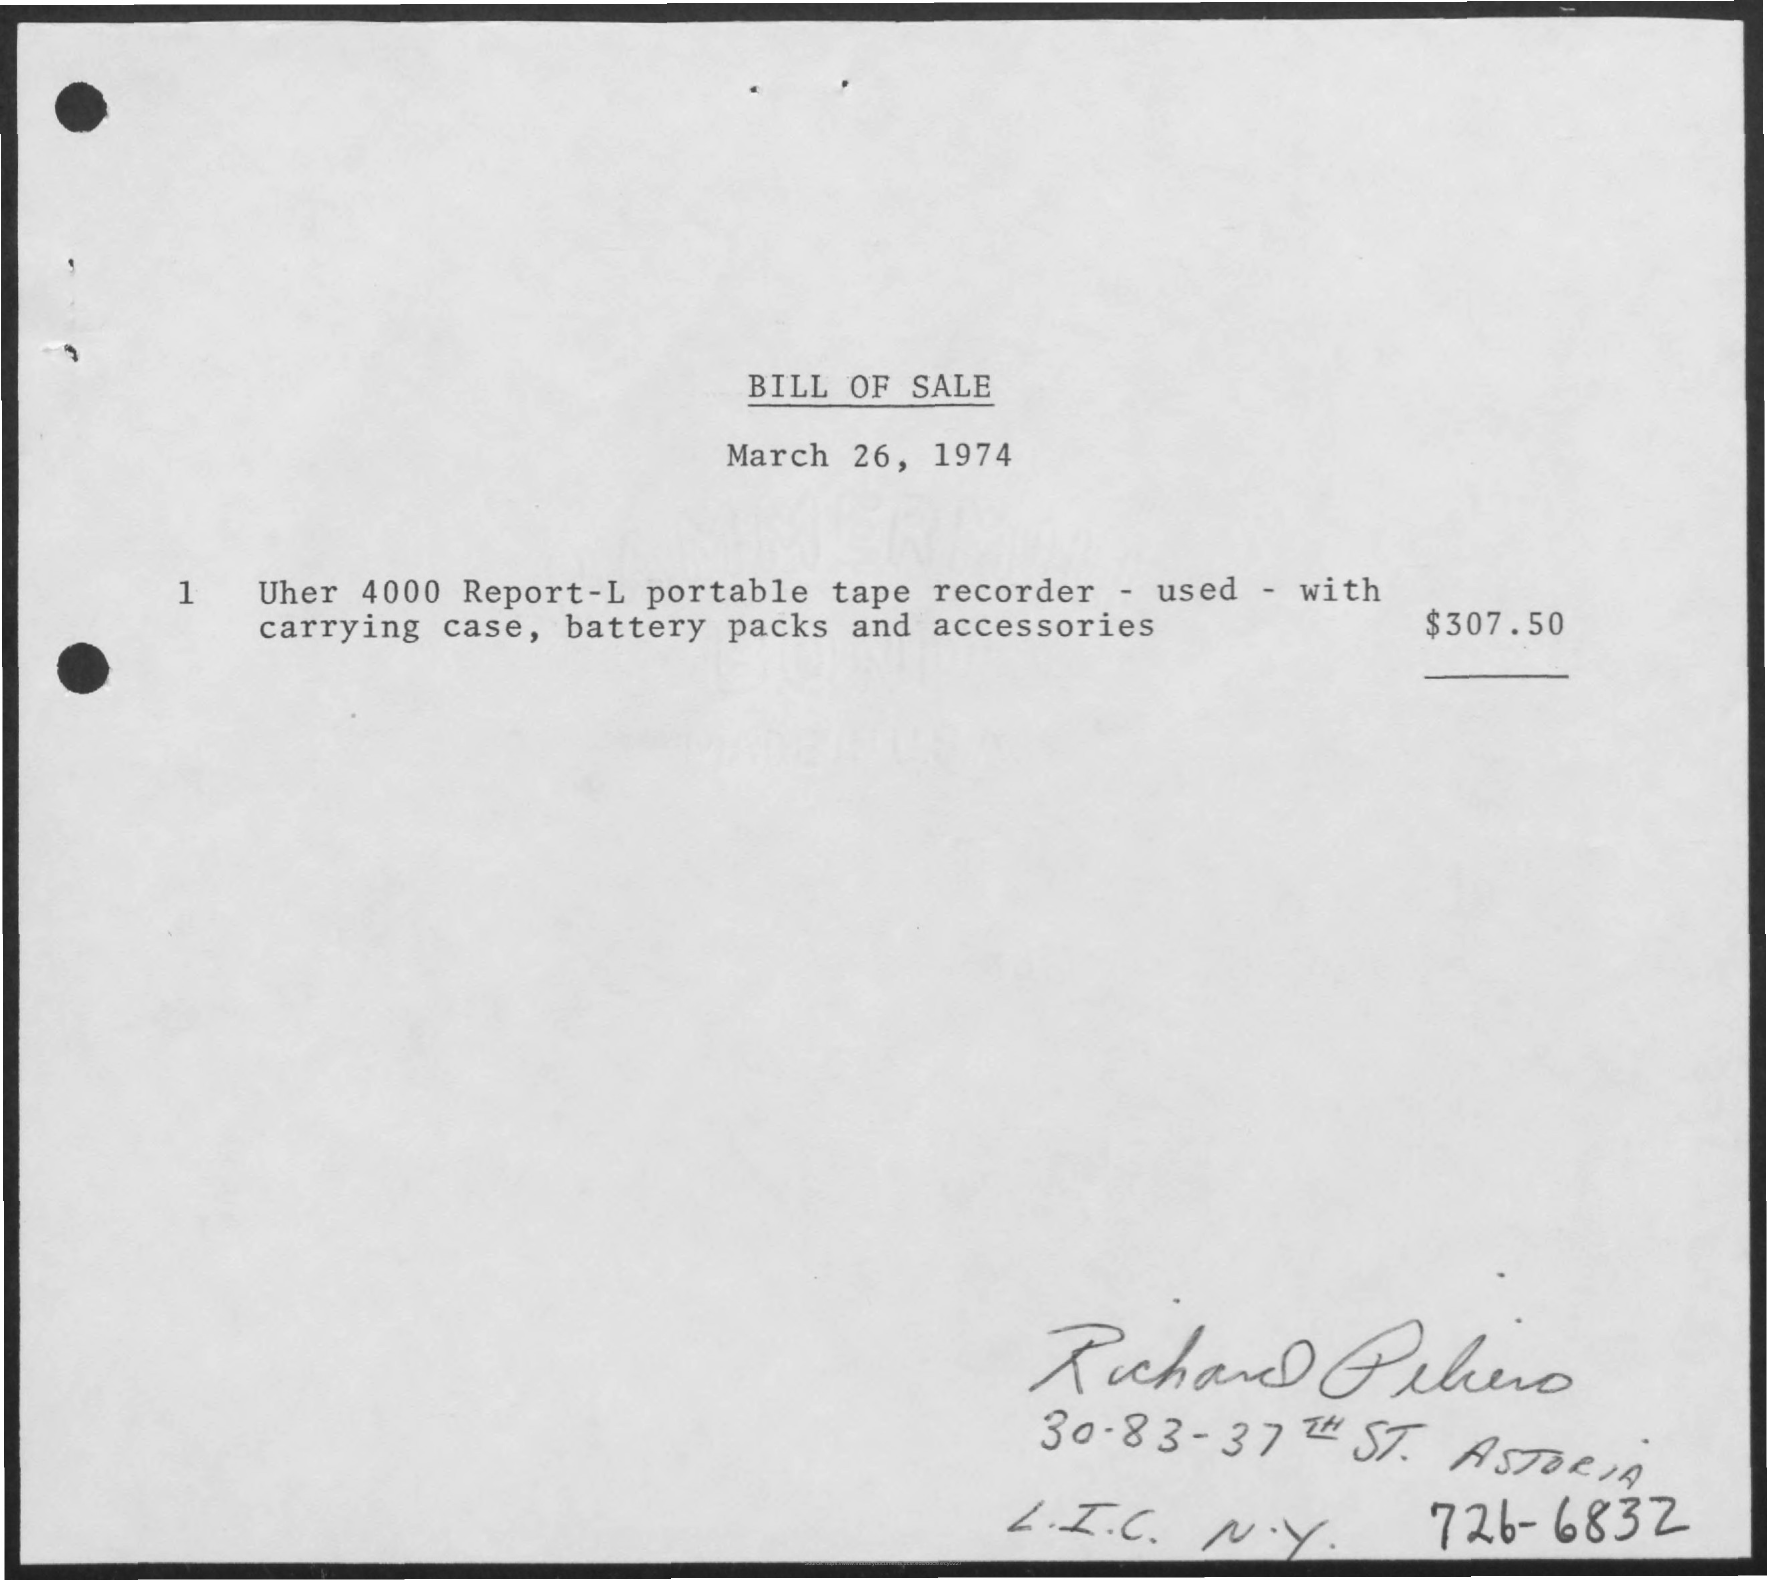What is the Title of the document?
Offer a terse response. Bill of Sale. What is the date on the document?
Offer a very short reply. March 26, 1974. 